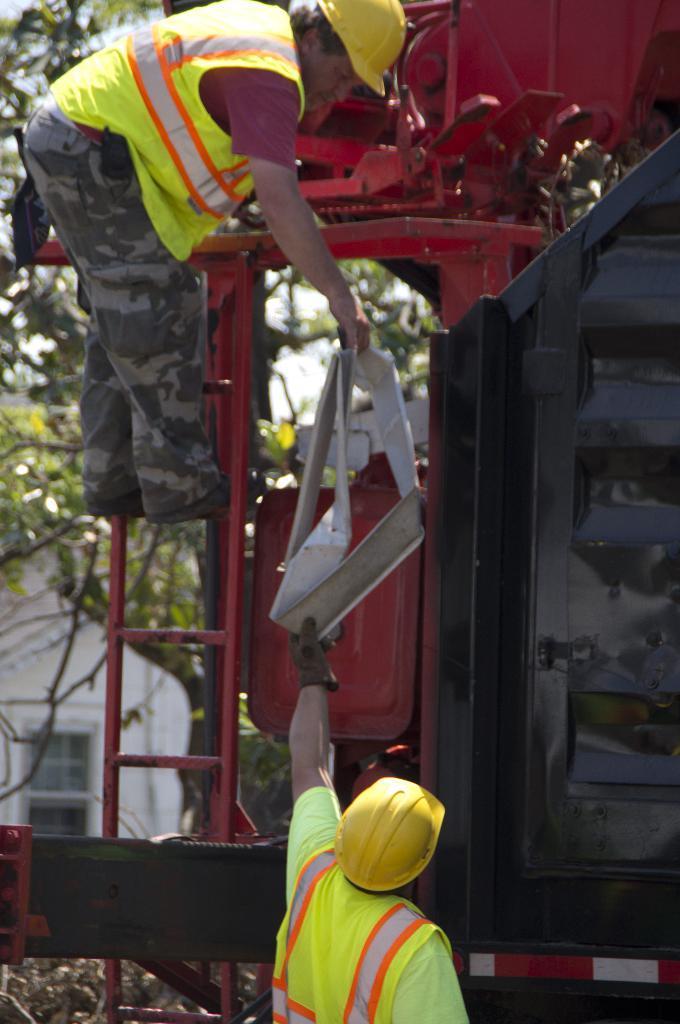Describe this image in one or two sentences. In this picture we can observe two men wearing green and yellow color helmets on their heads. One of the men is on the red color ladder and the other is on the land. In the background we can observe a house and some trees. 